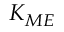Convert formula to latex. <formula><loc_0><loc_0><loc_500><loc_500>K _ { M E }</formula> 